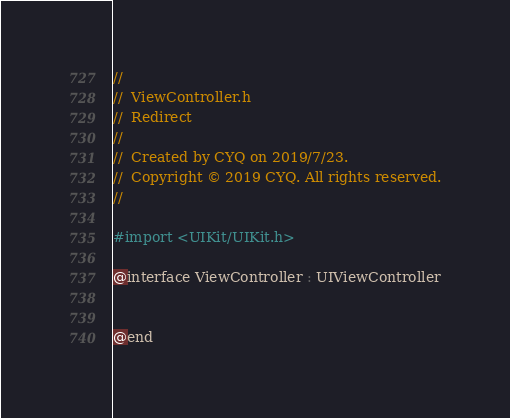Convert code to text. <code><loc_0><loc_0><loc_500><loc_500><_C_>//
//  ViewController.h
//  Redirect
//
//  Created by CYQ on 2019/7/23.
//  Copyright © 2019 CYQ. All rights reserved.
//

#import <UIKit/UIKit.h>

@interface ViewController : UIViewController


@end

</code> 